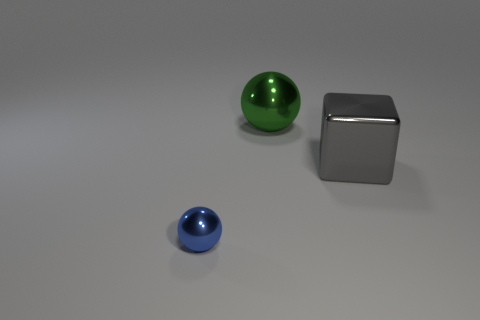Add 2 big gray metal things. How many objects exist? 5 Subtract all spheres. How many objects are left? 1 Add 3 red objects. How many red objects exist? 3 Subtract 0 purple cubes. How many objects are left? 3 Subtract all blue metallic things. Subtract all blue metal spheres. How many objects are left? 1 Add 2 big green things. How many big green things are left? 3 